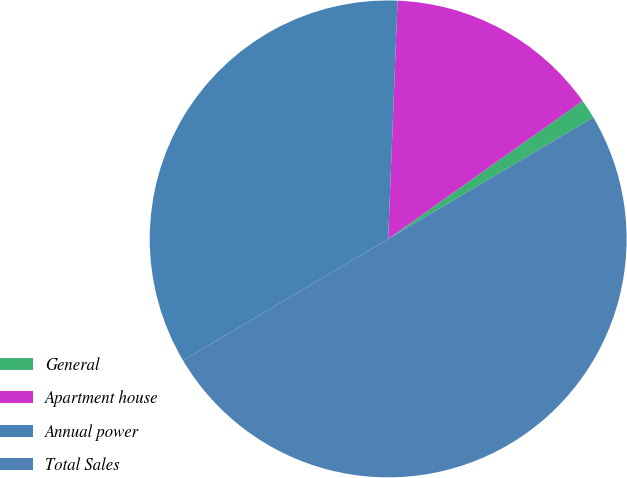Convert chart. <chart><loc_0><loc_0><loc_500><loc_500><pie_chart><fcel>General<fcel>Apartment house<fcel>Annual power<fcel>Total Sales<nl><fcel>1.31%<fcel>14.55%<fcel>34.14%<fcel>50.0%<nl></chart> 